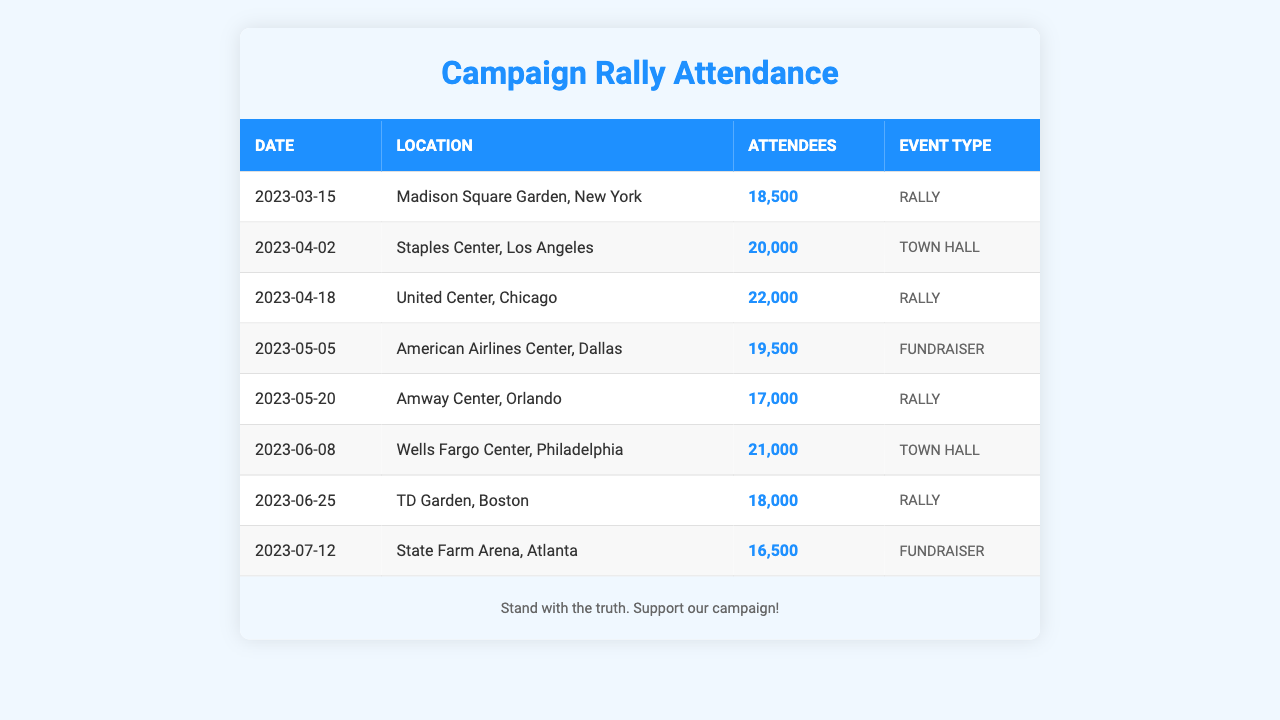What was the highest attendance number at a rally? The highest attendance number is found in the event at United Center, Chicago, on April 18, with 22,000 attendees.
Answer: 22,000 What event type had the lowest attendance? The lowest attendance is from a fundraiser held at State Farm Arena, Atlanta, on July 12, with 16,500 attendees.
Answer: Fundraiser What is the total attendance across all events listed in the table? The total attendance is calculated by summing all attendees: 18,500 + 20,000 + 22,000 + 19,500 + 17,000 + 21,000 + 18,000 + 16,500 = 132,500.
Answer: 132,500 Did all the events have more than 15,000 attendees? Checking each event, all have attendees above 15,000, confirming the statement is true.
Answer: Yes What is the average number of attendees at the rallies? The rallies and their attendance are: 18,500, 22,000, 17,000, and 18,000. Summing these (18,500 + 22,000 + 17,000 + 18,000 = 75,500), then dividing by 4 gives an average of 18,875.
Answer: 18,875 Which location had the highest attendance for a Town Hall event? The Town Hall events are in Los Angeles (20,000 attendees) and Philadelphia (21,000 attendees). The highest is in Philadelphia.
Answer: Philadelphia What event type was held in the most locations? By counting the event types and their occurrences, Rally appears four times, more than any other type.
Answer: Rally Is there an event type that had an attendance of exactly 19,500? There is one event, the fundraiser on May 5 in Dallas, that has precisely 19,500 attendees.
Answer: Yes What was the difference in attendance between the highest and lowest attending rally? The highest attending rally has 22,000 attendees at the United Center, and the lowest at Amway Center has 17,000. The difference (22,000 - 17,000 = 5,000) shows the gap in attendance.
Answer: 5,000 How many events took place in 2023 after May? The events after May are from June and July; specifically, there are three events: two Town Halls (June) and one Fundraiser (July).
Answer: 3 Which event type had an average attendance of 20,000 or more? To find this, we analyze Town Hall events with 20,000 and 21,000 attendees, averaging 20,500, which is greater than 20,000.
Answer: Yes 